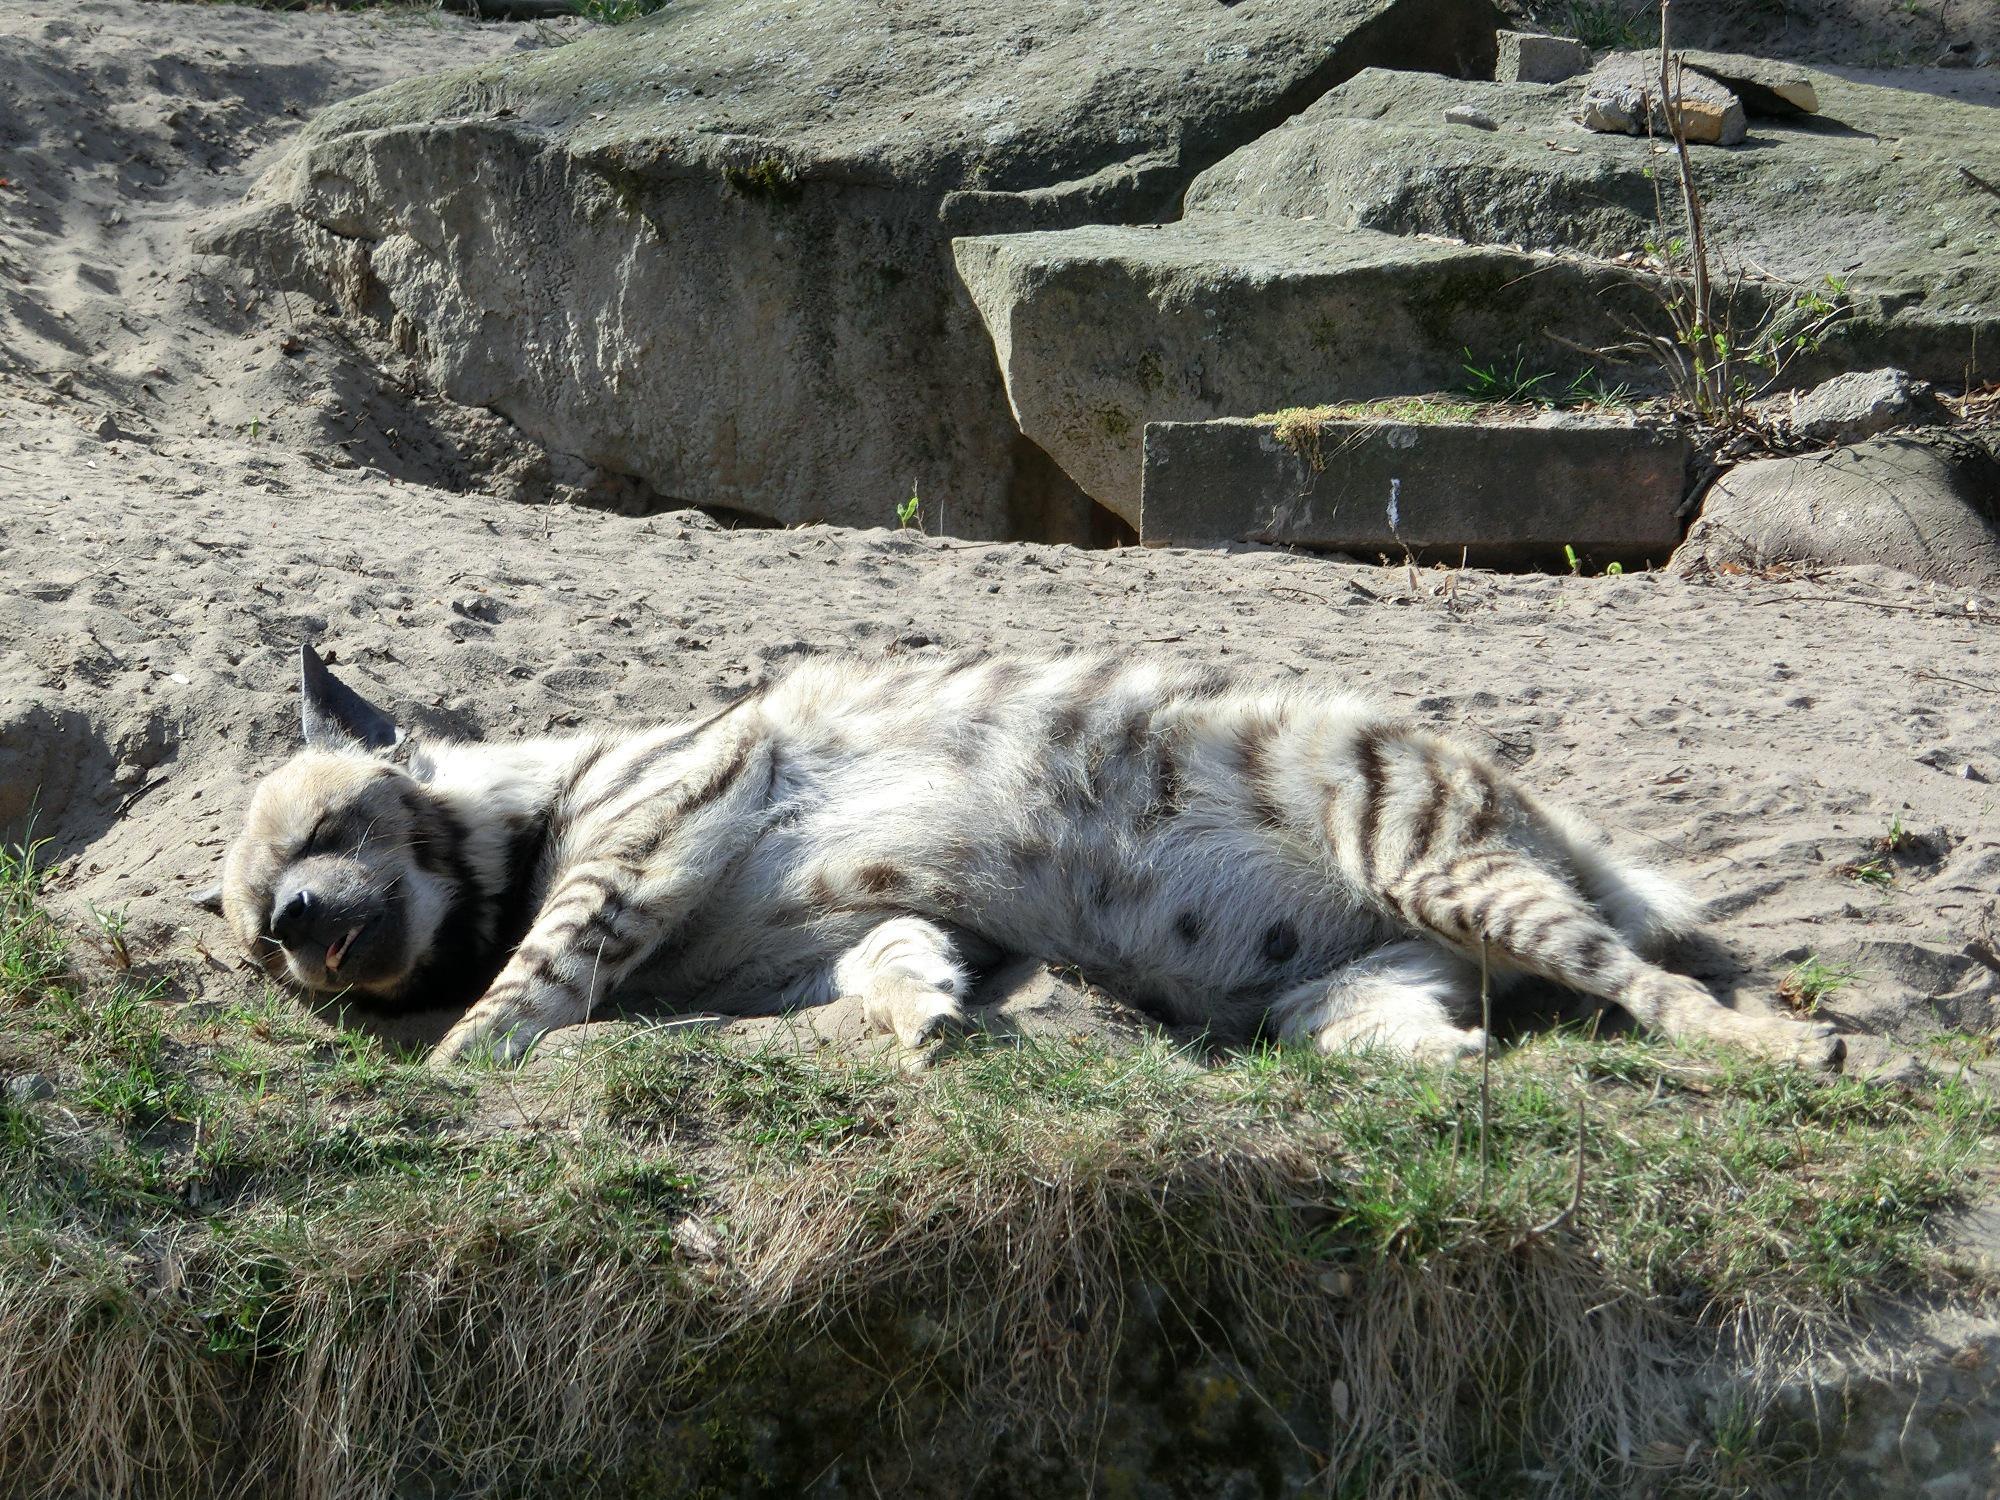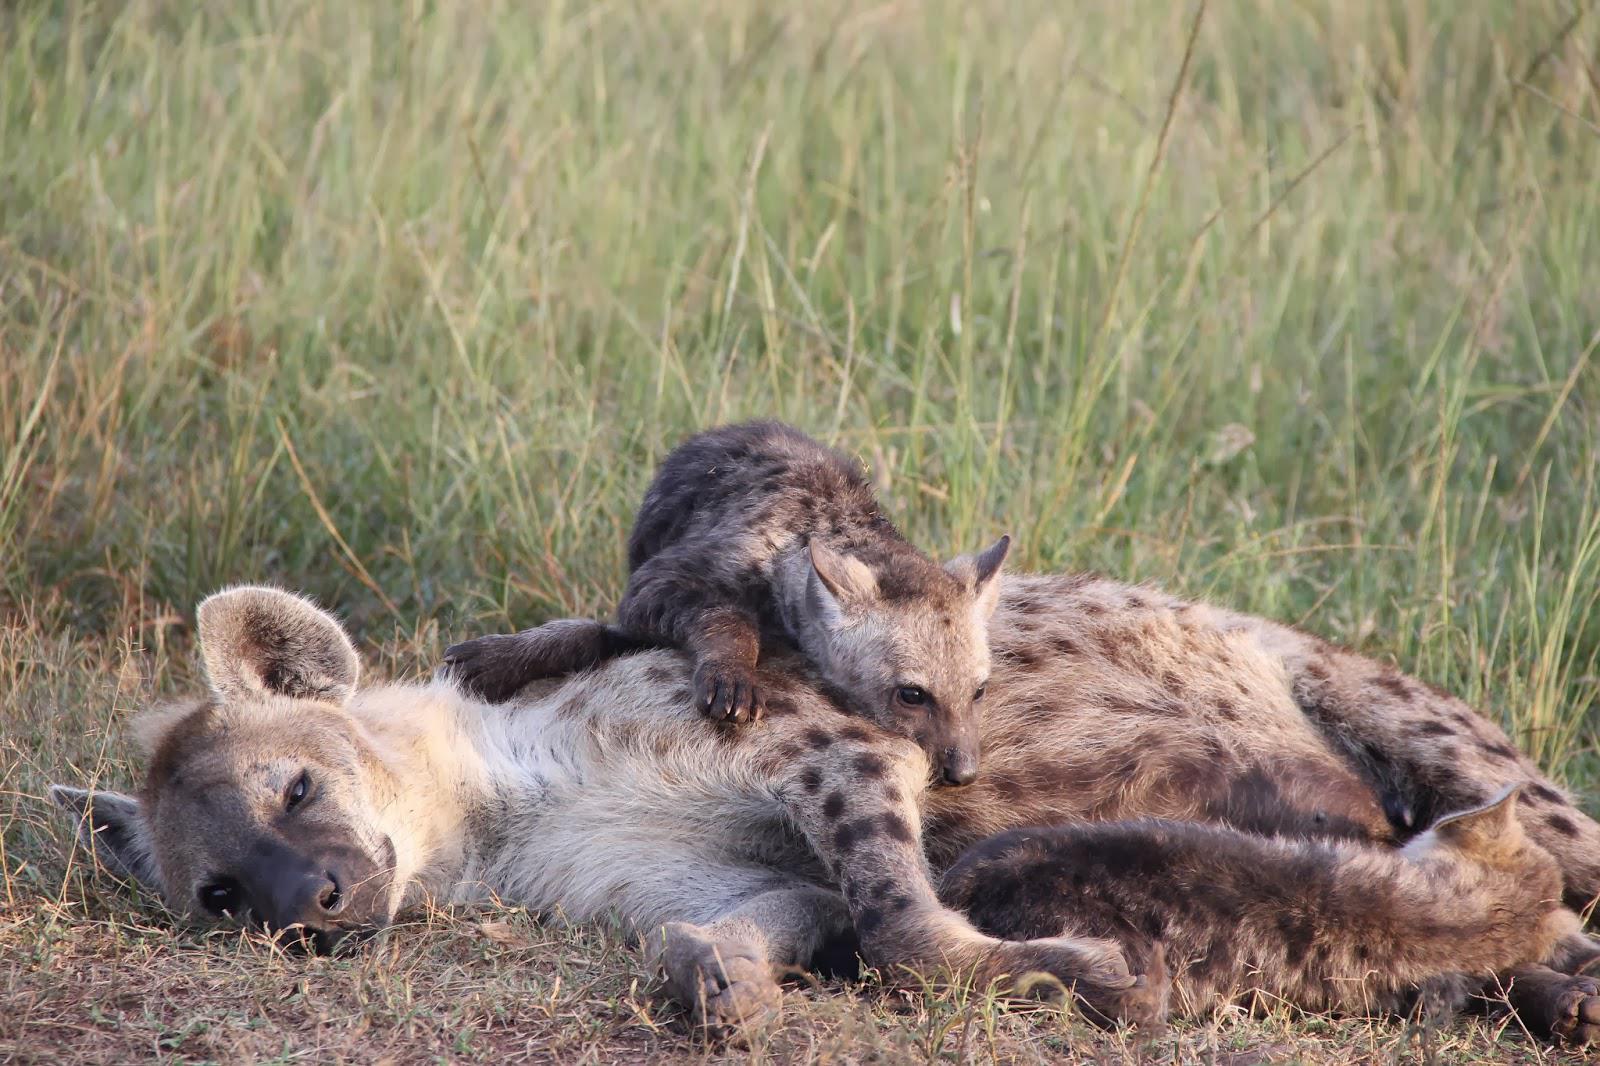The first image is the image on the left, the second image is the image on the right. For the images displayed, is the sentence "A hyena is laying on another hyena." factually correct? Answer yes or no. Yes. The first image is the image on the left, the second image is the image on the right. For the images shown, is this caption "Each image shows a reclining hyena with its body turned forward, and the right image features a reclining adult hyena with at least one hyena pup draped over it." true? Answer yes or no. Yes. 